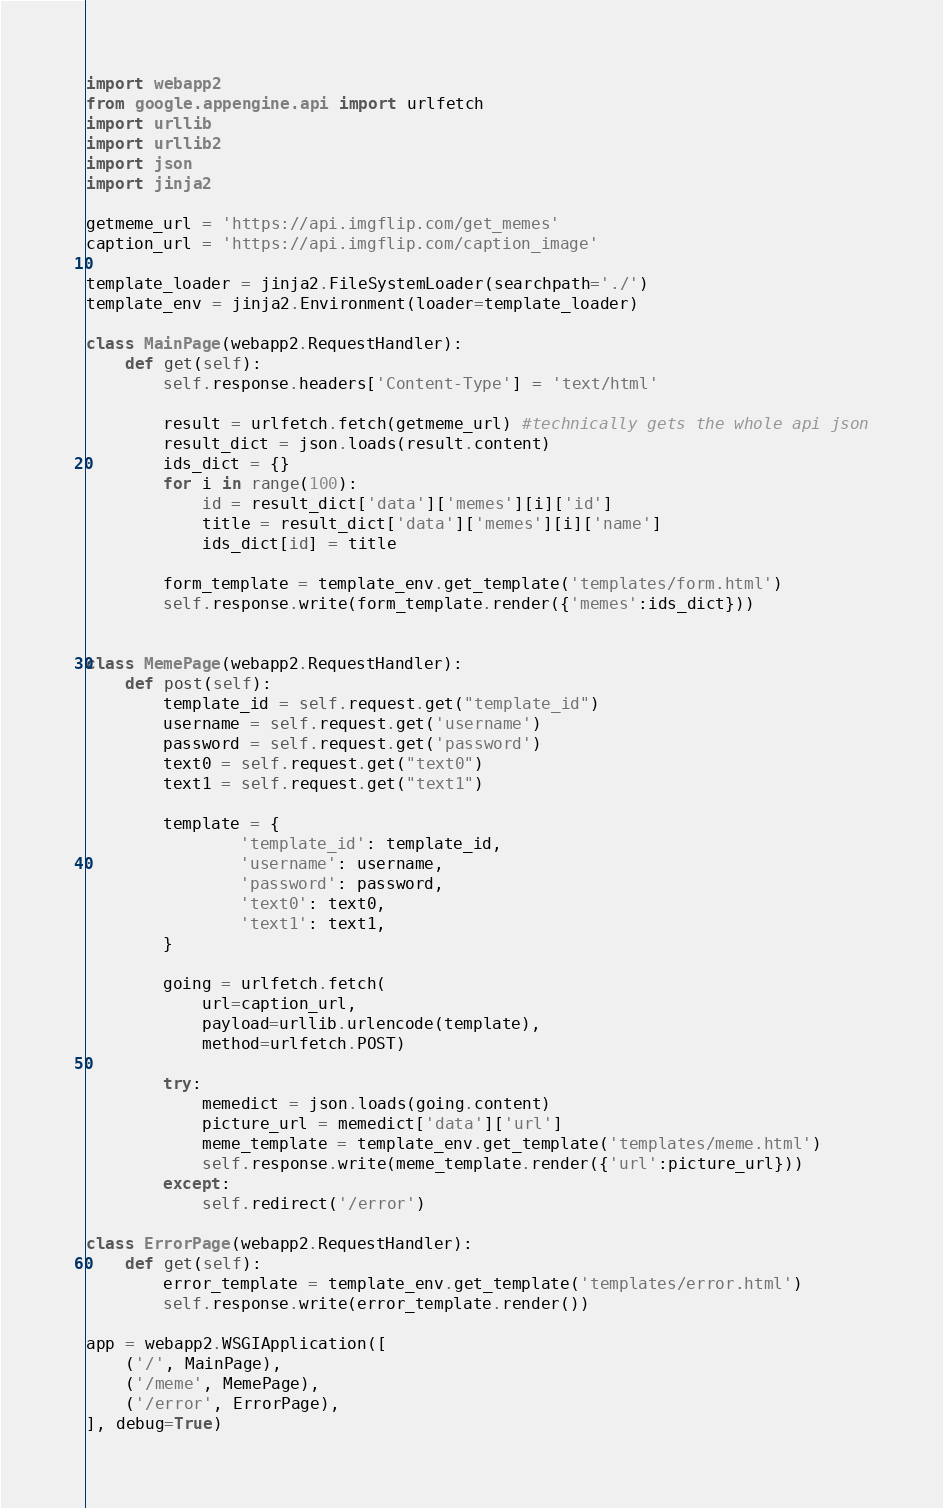Convert code to text. <code><loc_0><loc_0><loc_500><loc_500><_Python_>import webapp2
from google.appengine.api import urlfetch
import urllib
import urllib2
import json
import jinja2

getmeme_url = 'https://api.imgflip.com/get_memes'
caption_url = 'https://api.imgflip.com/caption_image'

template_loader = jinja2.FileSystemLoader(searchpath='./')
template_env = jinja2.Environment(loader=template_loader)

class MainPage(webapp2.RequestHandler):
    def get(self):
        self.response.headers['Content-Type'] = 'text/html'

        result = urlfetch.fetch(getmeme_url) #technically gets the whole api json
        result_dict = json.loads(result.content)
        ids_dict = {}
        for i in range(100):
            id = result_dict['data']['memes'][i]['id']
            title = result_dict['data']['memes'][i]['name']
            ids_dict[id] = title

        form_template = template_env.get_template('templates/form.html')
        self.response.write(form_template.render({'memes':ids_dict}))


class MemePage(webapp2.RequestHandler):
    def post(self):
        template_id = self.request.get("template_id")
        username = self.request.get('username')
        password = self.request.get('password')
        text0 = self.request.get("text0")
        text1 = self.request.get("text1")

        template = {
                'template_id': template_id,
                'username': username,
                'password': password,
                'text0': text0,
                'text1': text1,
        }

        going = urlfetch.fetch(
            url=caption_url,
            payload=urllib.urlencode(template),
            method=urlfetch.POST)

        try:
            memedict = json.loads(going.content)
            picture_url = memedict['data']['url']
            meme_template = template_env.get_template('templates/meme.html')
            self.response.write(meme_template.render({'url':picture_url}))
        except:
            self.redirect('/error')

class ErrorPage(webapp2.RequestHandler):
    def get(self):
        error_template = template_env.get_template('templates/error.html')
        self.response.write(error_template.render())

app = webapp2.WSGIApplication([
    ('/', MainPage),
    ('/meme', MemePage),
    ('/error', ErrorPage),
], debug=True)
</code> 